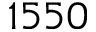<formula> <loc_0><loc_0><loc_500><loc_500>1 5 5 0</formula> 